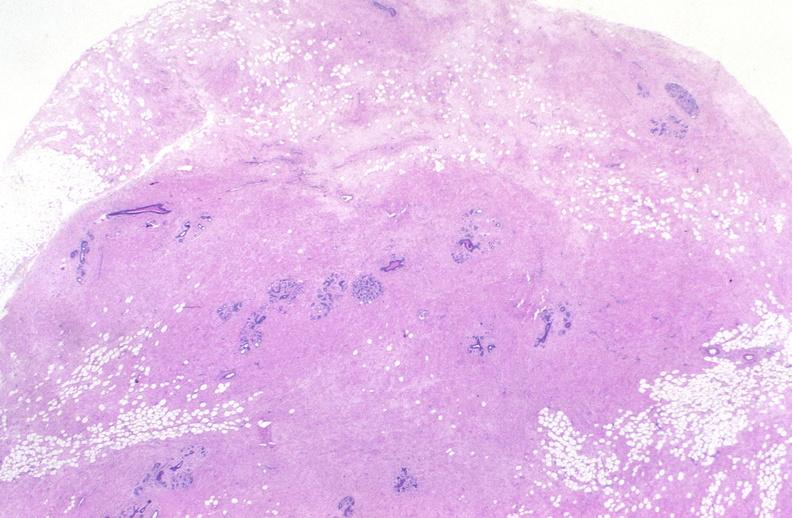does liver show breast, fibroadenoma?
Answer the question using a single word or phrase. No 